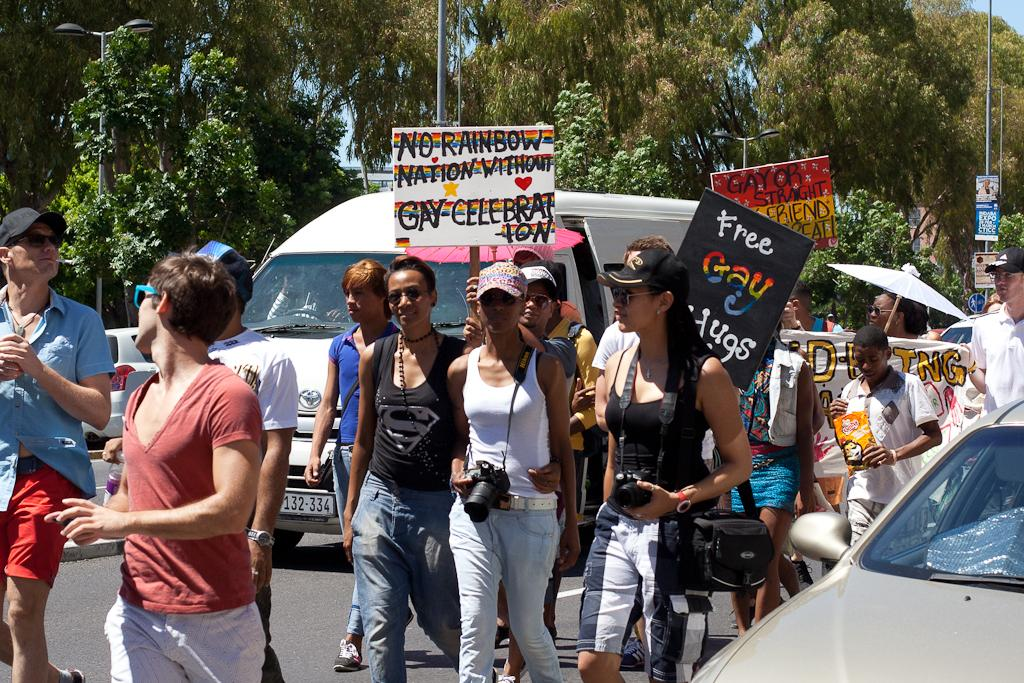What types of objects can be seen in the image? There are vehicles, cameras, bags, a banner, boards, umbrellas, poles, and trees visible in the image. What are the people in the image doing? There is a group of people walking on the road in the image. What might be used for capturing images in the image? Cameras are present in the image. What is hanging above the road in the image? A banner is visible in the image. What might be used for providing shade or protection from the rain in the image? Umbrellas are in the image. What is visible in the background of the image? The sky is visible in the background of the image. What type of calendar is hanging on the tree in the image? There is no calendar present in the image; only vehicles, people, cameras, bags, a banner, boards, umbrellas, poles, and trees are visible. What is the shape of the lip on the vehicle in the image? There is no lip present on any of the vehicles in the image. 